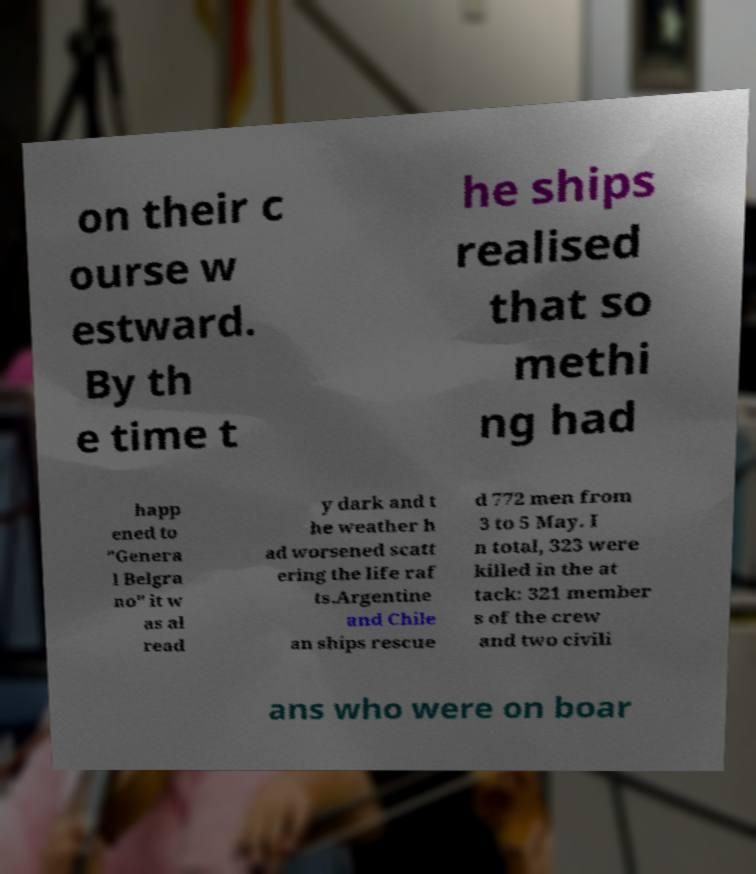Please read and relay the text visible in this image. What does it say? on their c ourse w estward. By th e time t he ships realised that so methi ng had happ ened to "Genera l Belgra no" it w as al read y dark and t he weather h ad worsened scatt ering the life raf ts.Argentine and Chile an ships rescue d 772 men from 3 to 5 May. I n total, 323 were killed in the at tack: 321 member s of the crew and two civili ans who were on boar 